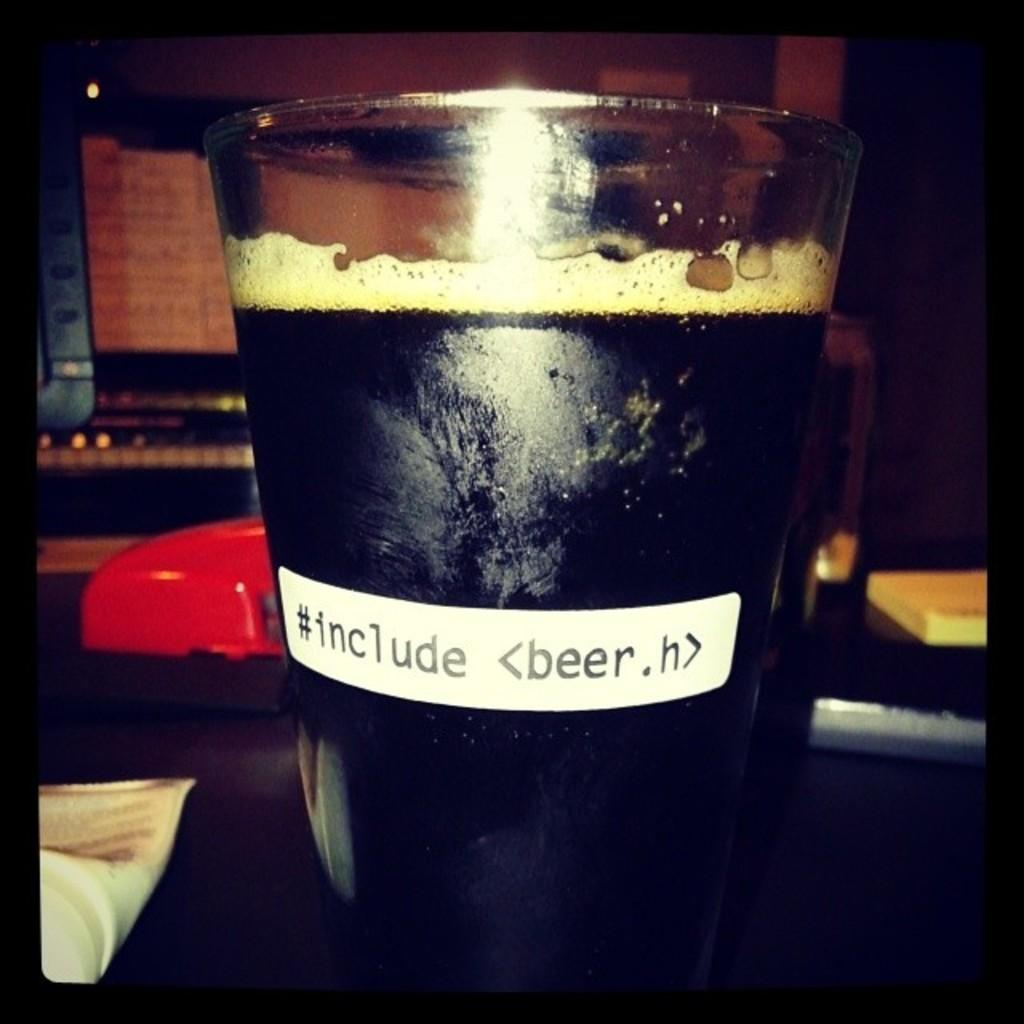<image>
Create a compact narrative representing the image presented. A pint glass of dark ale has a sticker on it which says #include <beer.h> 